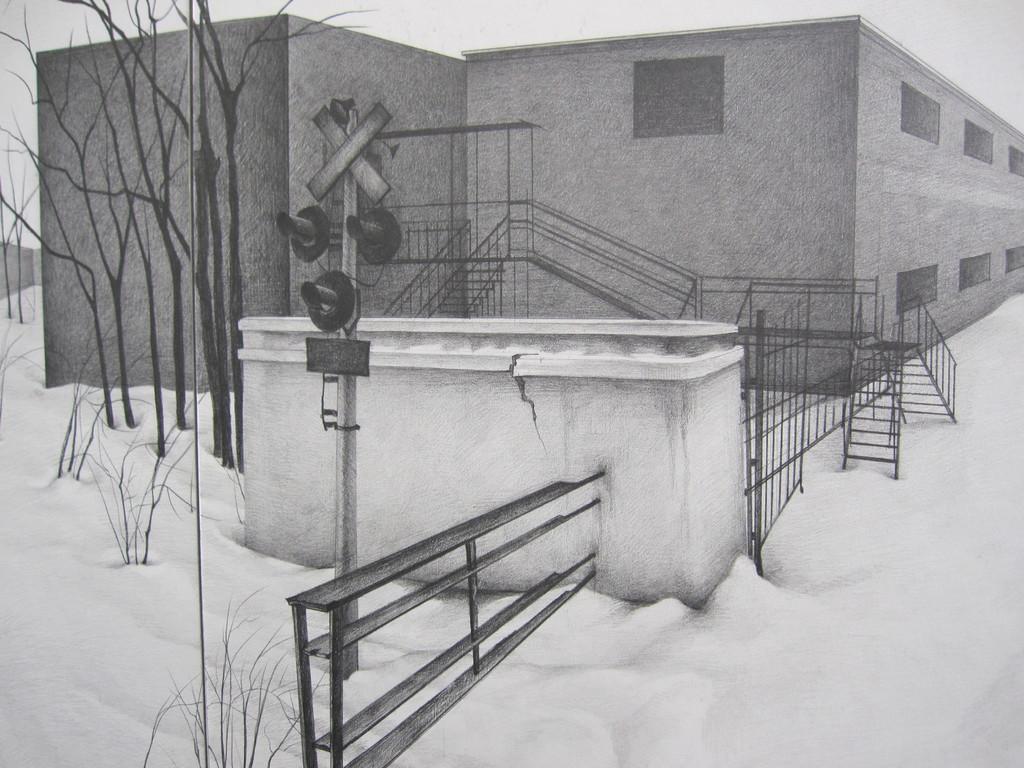Describe this image in one or two sentences. In this image in the front there is a railing and this is the painting image in which there is snow on the ground and there is a building and there are stairs and there are trees. 